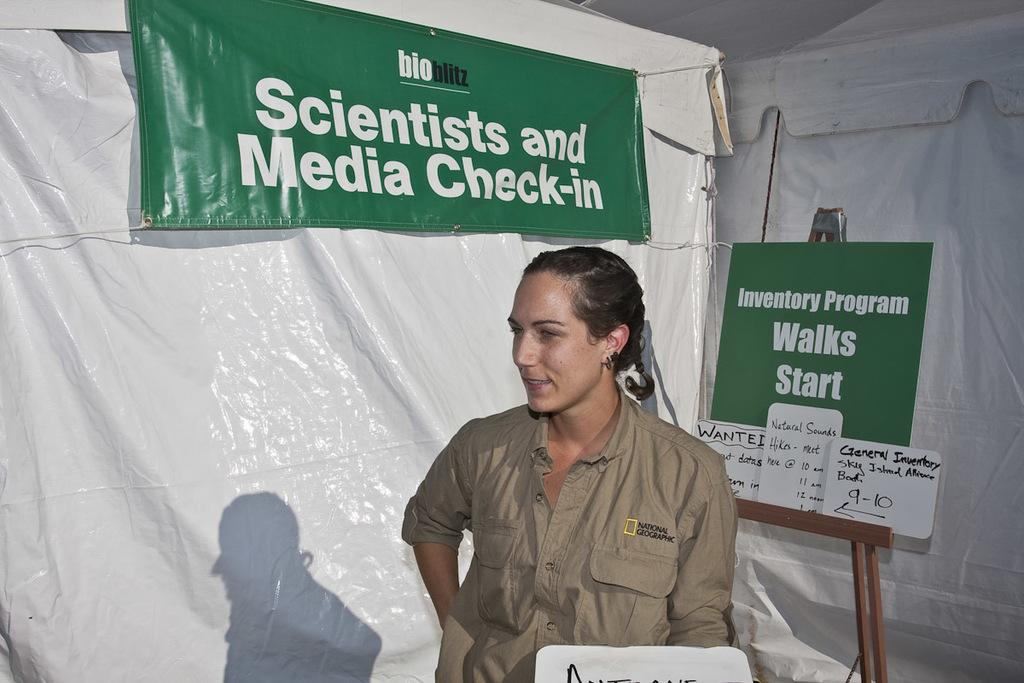Who is present in the image? There is a woman in the image. Where is the woman located? The woman is inside a tent. What else can be seen in the image besides the woman? There are hoardings visible in the image. What type of hat is the woman wearing in the image? There is no hat visible in the image; the woman is inside a tent. How does the woman enforce rules in the image? The image does not show the woman enforcing any rules, nor does it provide any information about her role or authority. 